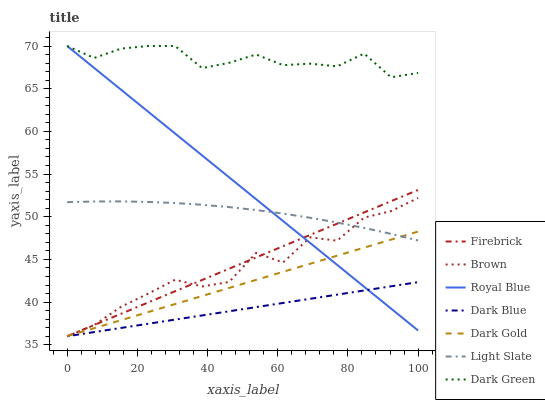Does Royal Blue have the minimum area under the curve?
Answer yes or no. No. Does Royal Blue have the maximum area under the curve?
Answer yes or no. No. Is Royal Blue the smoothest?
Answer yes or no. No. Is Royal Blue the roughest?
Answer yes or no. No. Does Royal Blue have the lowest value?
Answer yes or no. No. Does Dark Gold have the highest value?
Answer yes or no. No. Is Firebrick less than Dark Green?
Answer yes or no. Yes. Is Dark Green greater than Light Slate?
Answer yes or no. Yes. Does Firebrick intersect Dark Green?
Answer yes or no. No. 